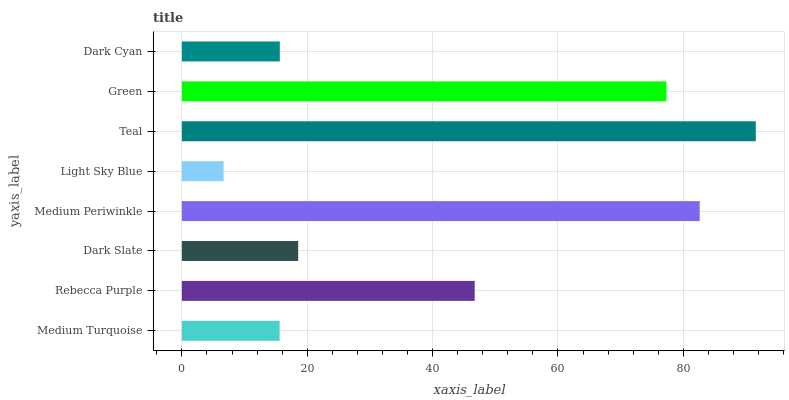Is Light Sky Blue the minimum?
Answer yes or no. Yes. Is Teal the maximum?
Answer yes or no. Yes. Is Rebecca Purple the minimum?
Answer yes or no. No. Is Rebecca Purple the maximum?
Answer yes or no. No. Is Rebecca Purple greater than Medium Turquoise?
Answer yes or no. Yes. Is Medium Turquoise less than Rebecca Purple?
Answer yes or no. Yes. Is Medium Turquoise greater than Rebecca Purple?
Answer yes or no. No. Is Rebecca Purple less than Medium Turquoise?
Answer yes or no. No. Is Rebecca Purple the high median?
Answer yes or no. Yes. Is Dark Slate the low median?
Answer yes or no. Yes. Is Dark Slate the high median?
Answer yes or no. No. Is Medium Periwinkle the low median?
Answer yes or no. No. 